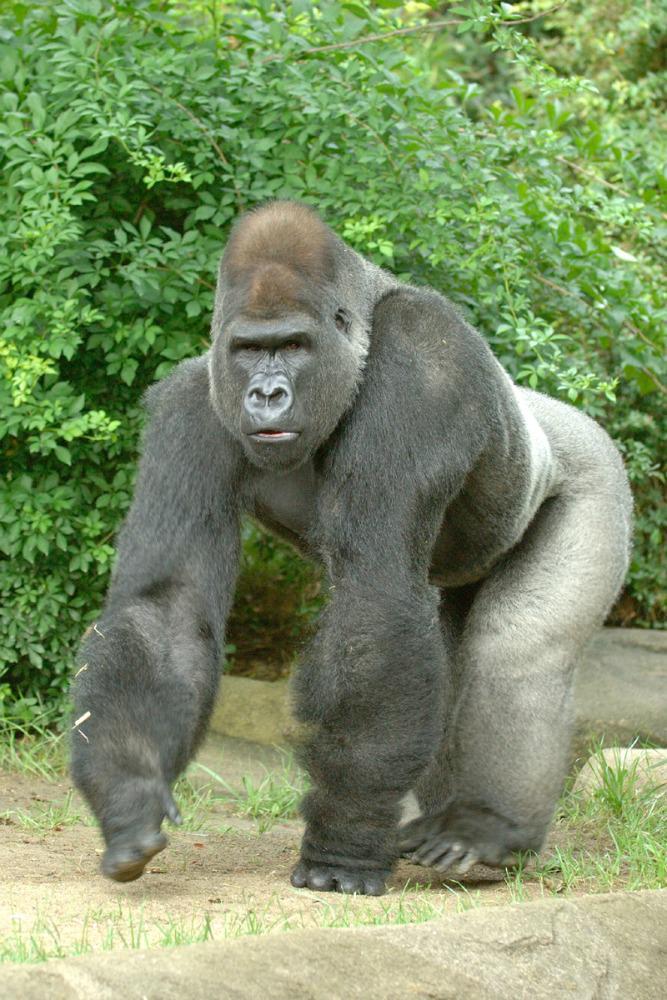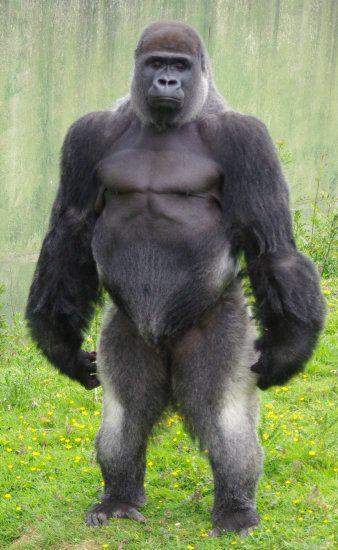The first image is the image on the left, the second image is the image on the right. For the images displayed, is the sentence "An image includes a baby gorilla with at least one adult gorilla." factually correct? Answer yes or no. No. The first image is the image on the left, the second image is the image on the right. Considering the images on both sides, is "A baby gorilla is being carried by its mother." valid? Answer yes or no. No. 